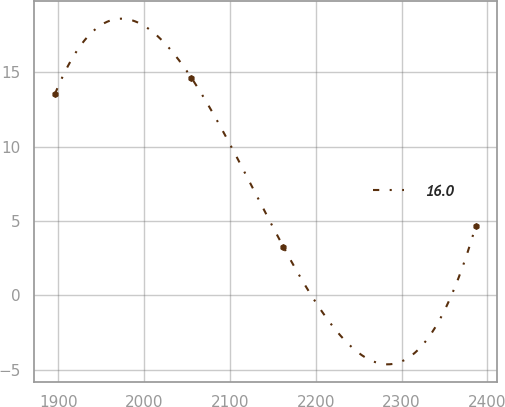Convert chart. <chart><loc_0><loc_0><loc_500><loc_500><line_chart><ecel><fcel>16.0<nl><fcel>1895.85<fcel>13.53<nl><fcel>2054.98<fcel>14.61<nl><fcel>2162.28<fcel>3.25<nl><fcel>2386.24<fcel>4.63<nl></chart> 